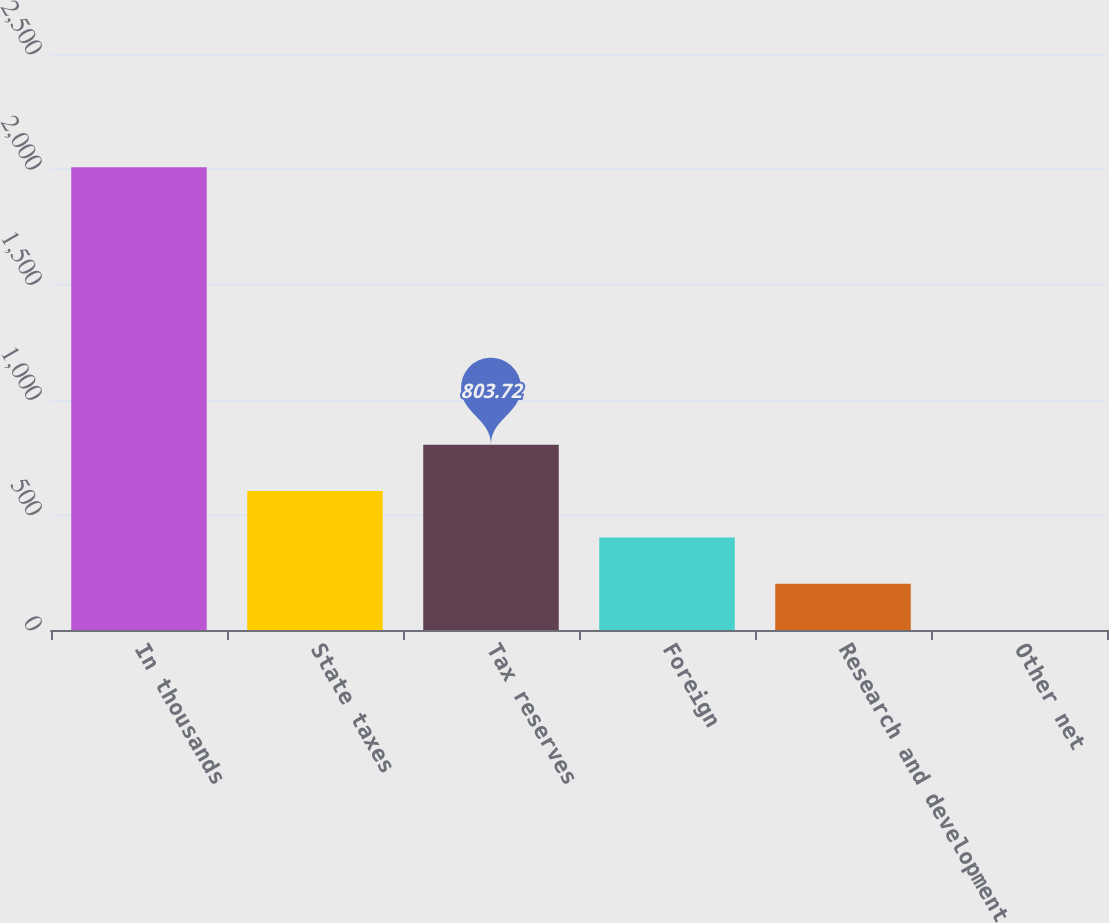<chart> <loc_0><loc_0><loc_500><loc_500><bar_chart><fcel>In thousands<fcel>State taxes<fcel>Tax reserves<fcel>Foreign<fcel>Research and development<fcel>Other net<nl><fcel>2009<fcel>602.84<fcel>803.72<fcel>401.96<fcel>201.08<fcel>0.2<nl></chart> 